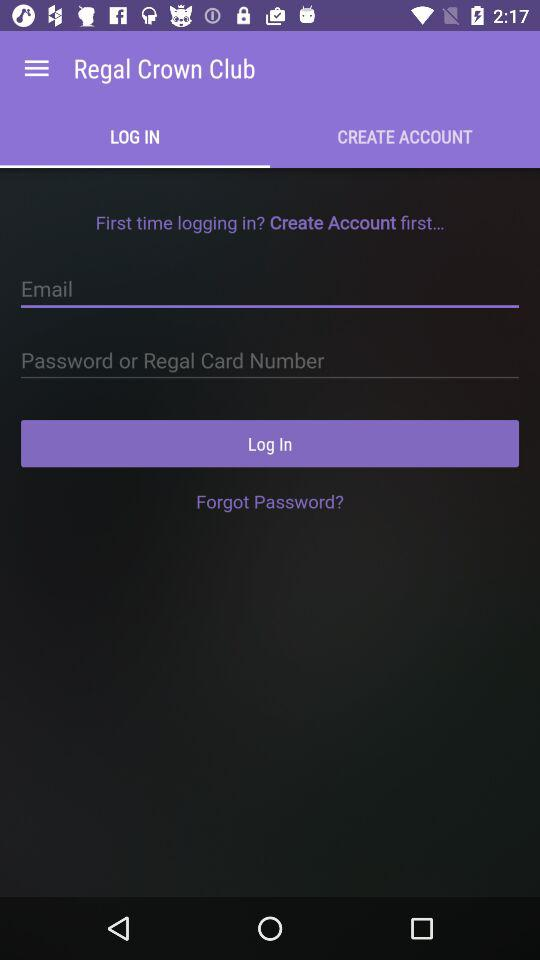Which option is selected in "Regal Crown Club"? The selected option in "Regal Crown Club" is "LOG IN". 